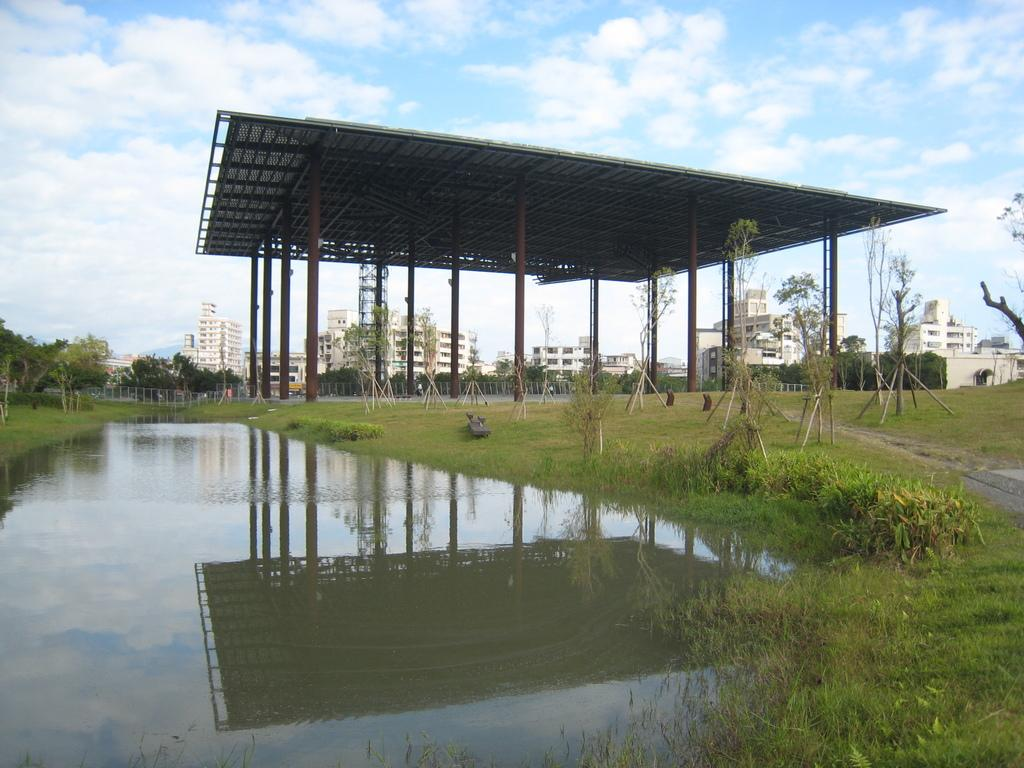What is one of the natural elements present in the image? There is water in the image. What type of vegetation can be seen in the image? There is grass and trees in the image. What type of structure is present in the image? There is a shed in the image. What type of man-made structures can be seen in the image? There are buildings in the image. How would you describe the sky in the image? The sky is blue with clouds in the background. How many ladybugs are crawling on the buildings in the image? There are no ladybugs present in the image; it only features water, grass, trees, a shed, buildings, and a blue sky with clouds. 